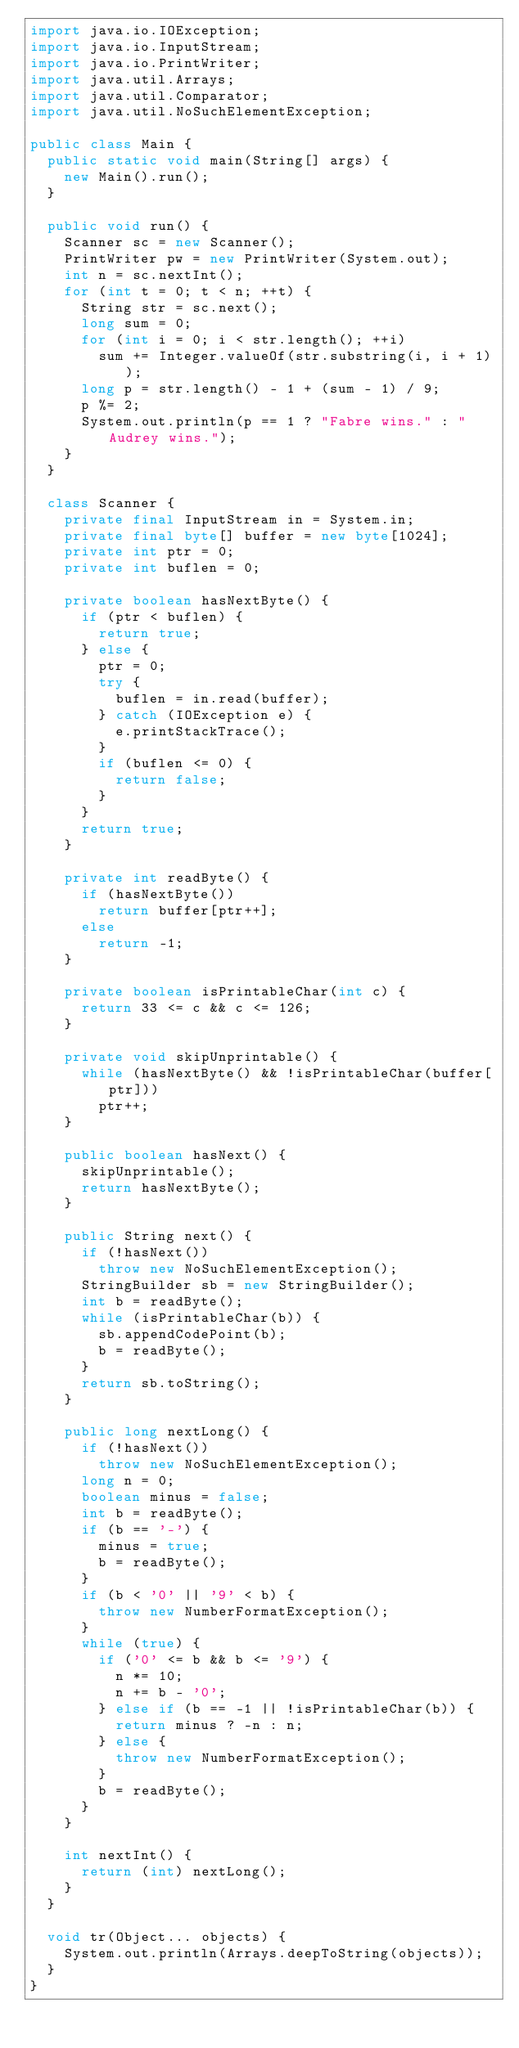<code> <loc_0><loc_0><loc_500><loc_500><_Java_>import java.io.IOException;
import java.io.InputStream;
import java.io.PrintWriter;
import java.util.Arrays;
import java.util.Comparator;
import java.util.NoSuchElementException;

public class Main {
	public static void main(String[] args) {
		new Main().run();
	}

	public void run() {
		Scanner sc = new Scanner();
		PrintWriter pw = new PrintWriter(System.out);
		int n = sc.nextInt();
		for (int t = 0; t < n; ++t) {
			String str = sc.next();
			long sum = 0;
			for (int i = 0; i < str.length(); ++i)
				sum += Integer.valueOf(str.substring(i, i + 1));
			long p = str.length() - 1 + (sum - 1) / 9;
			p %= 2;
			System.out.println(p == 1 ? "Fabre wins." : "Audrey wins.");
		}
	}

	class Scanner {
		private final InputStream in = System.in;
		private final byte[] buffer = new byte[1024];
		private int ptr = 0;
		private int buflen = 0;

		private boolean hasNextByte() {
			if (ptr < buflen) {
				return true;
			} else {
				ptr = 0;
				try {
					buflen = in.read(buffer);
				} catch (IOException e) {
					e.printStackTrace();
				}
				if (buflen <= 0) {
					return false;
				}
			}
			return true;
		}

		private int readByte() {
			if (hasNextByte())
				return buffer[ptr++];
			else
				return -1;
		}

		private boolean isPrintableChar(int c) {
			return 33 <= c && c <= 126;
		}

		private void skipUnprintable() {
			while (hasNextByte() && !isPrintableChar(buffer[ptr]))
				ptr++;
		}

		public boolean hasNext() {
			skipUnprintable();
			return hasNextByte();
		}

		public String next() {
			if (!hasNext())
				throw new NoSuchElementException();
			StringBuilder sb = new StringBuilder();
			int b = readByte();
			while (isPrintableChar(b)) {
				sb.appendCodePoint(b);
				b = readByte();
			}
			return sb.toString();
		}

		public long nextLong() {
			if (!hasNext())
				throw new NoSuchElementException();
			long n = 0;
			boolean minus = false;
			int b = readByte();
			if (b == '-') {
				minus = true;
				b = readByte();
			}
			if (b < '0' || '9' < b) {
				throw new NumberFormatException();
			}
			while (true) {
				if ('0' <= b && b <= '9') {
					n *= 10;
					n += b - '0';
				} else if (b == -1 || !isPrintableChar(b)) {
					return minus ? -n : n;
				} else {
					throw new NumberFormatException();
				}
				b = readByte();
			}
		}

		int nextInt() {
			return (int) nextLong();
		}
	}

	void tr(Object... objects) {
		System.out.println(Arrays.deepToString(objects));
	}
}
</code> 